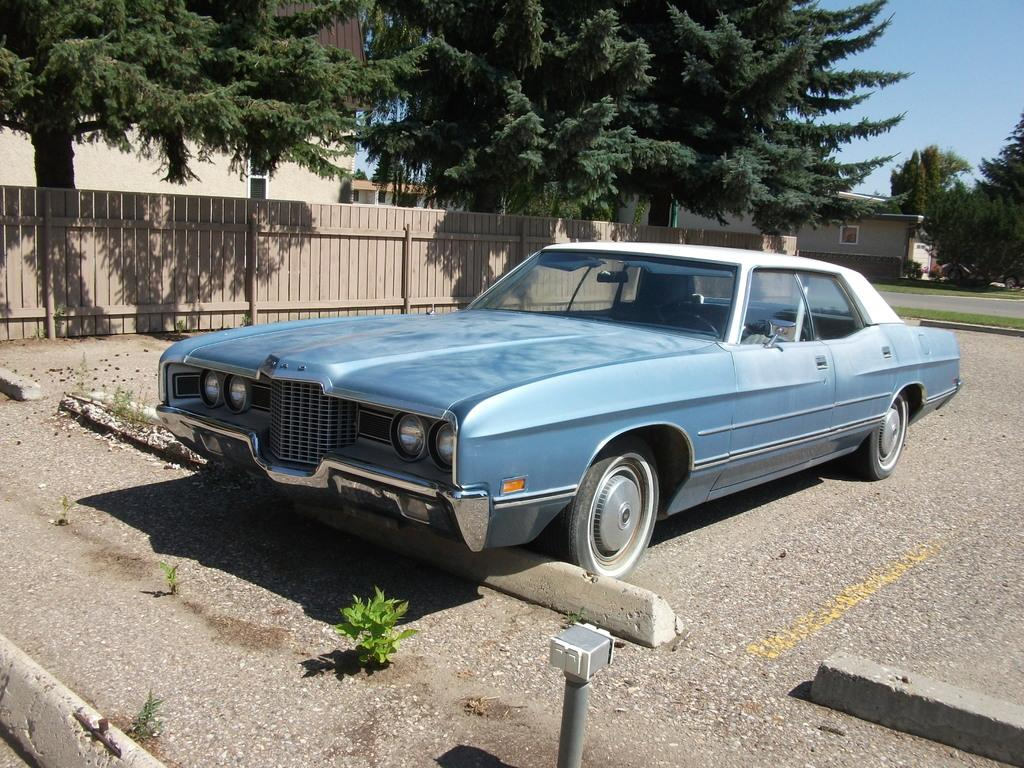What is the main subject of the image? There is a car on the road in the image. What can be seen behind the car? There is a wooden fencing behind the car. What is visible behind the wooden fencing? There are trees visible behind the wooden fencing. What structure is located on the right side of the image? There is a house on the right side of the image. How many feet of rice can be seen growing in the image? There is no rice visible in the image, so it is not possible to determine the amount of rice present. 